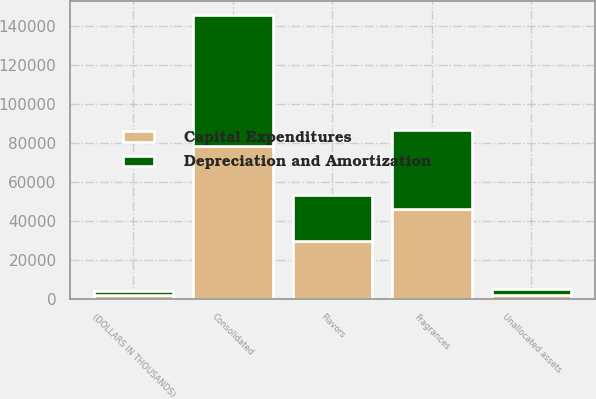<chart> <loc_0><loc_0><loc_500><loc_500><stacked_bar_chart><ecel><fcel>(DOLLARS IN THOUSANDS)<fcel>Flavors<fcel>Fragrances<fcel>Unallocated assets<fcel>Consolidated<nl><fcel>Depreciation and Amortization<fcel>2009<fcel>23463<fcel>40122<fcel>3234<fcel>66819<nl><fcel>Capital Expenditures<fcel>2009<fcel>29874<fcel>46410<fcel>2241<fcel>78525<nl></chart> 